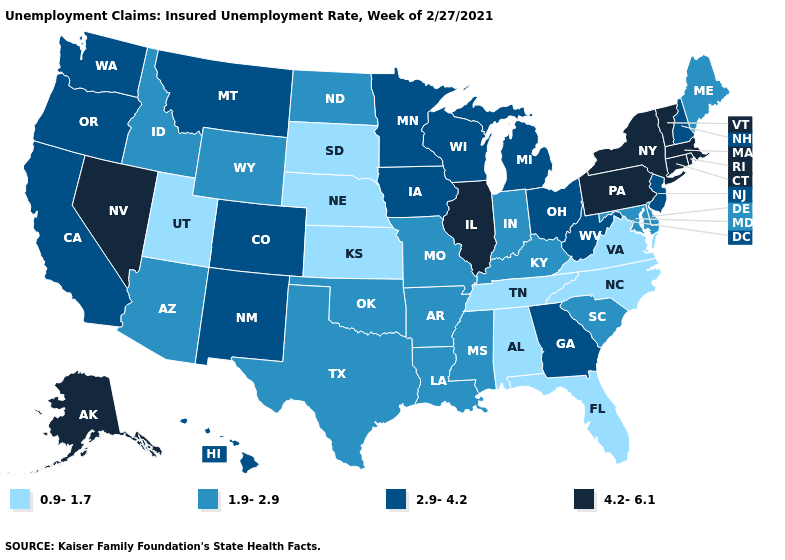Does Alaska have the highest value in the USA?
Be succinct. Yes. What is the value of Tennessee?
Give a very brief answer. 0.9-1.7. Does Delaware have a higher value than Kentucky?
Keep it brief. No. Is the legend a continuous bar?
Be succinct. No. What is the value of Pennsylvania?
Be succinct. 4.2-6.1. Name the states that have a value in the range 4.2-6.1?
Answer briefly. Alaska, Connecticut, Illinois, Massachusetts, Nevada, New York, Pennsylvania, Rhode Island, Vermont. Name the states that have a value in the range 0.9-1.7?
Short answer required. Alabama, Florida, Kansas, Nebraska, North Carolina, South Dakota, Tennessee, Utah, Virginia. Does Wyoming have the highest value in the USA?
Short answer required. No. Among the states that border Connecticut , which have the highest value?
Keep it brief. Massachusetts, New York, Rhode Island. What is the value of Nevada?
Concise answer only. 4.2-6.1. Name the states that have a value in the range 0.9-1.7?
Quick response, please. Alabama, Florida, Kansas, Nebraska, North Carolina, South Dakota, Tennessee, Utah, Virginia. Does the map have missing data?
Be succinct. No. What is the value of Wisconsin?
Give a very brief answer. 2.9-4.2. Does Pennsylvania have the lowest value in the Northeast?
Give a very brief answer. No. What is the value of Illinois?
Quick response, please. 4.2-6.1. 